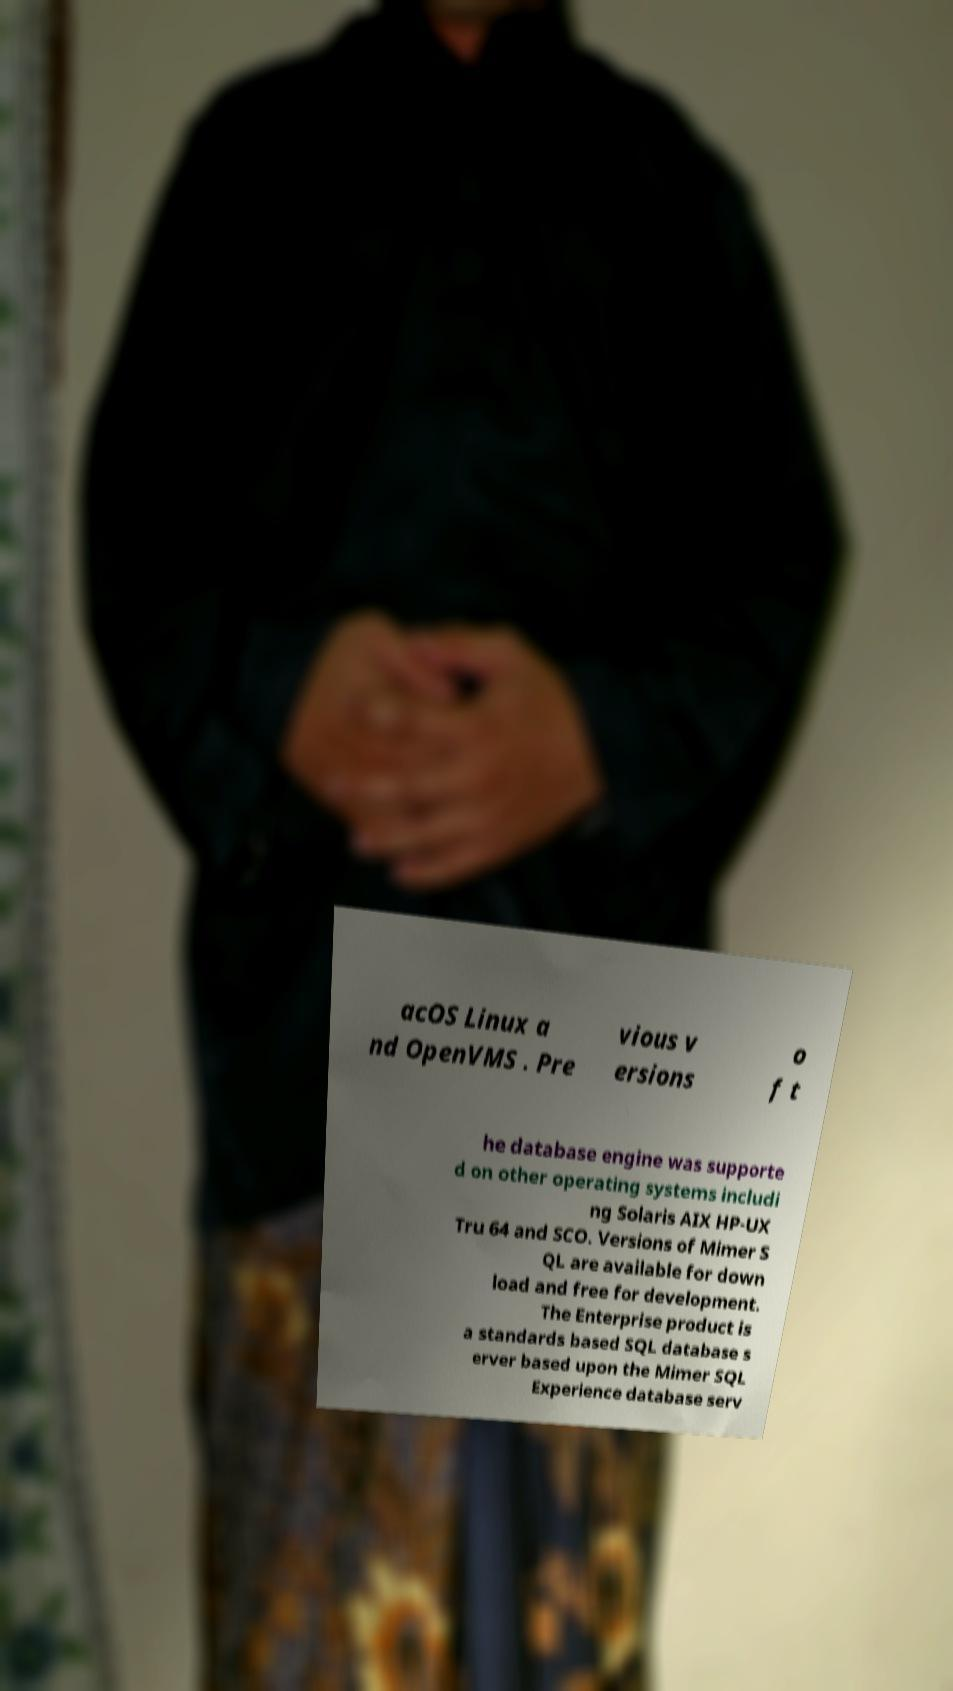There's text embedded in this image that I need extracted. Can you transcribe it verbatim? acOS Linux a nd OpenVMS . Pre vious v ersions o f t he database engine was supporte d on other operating systems includi ng Solaris AIX HP-UX Tru 64 and SCO. Versions of Mimer S QL are available for down load and free for development. The Enterprise product is a standards based SQL database s erver based upon the Mimer SQL Experience database serv 